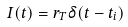Convert formula to latex. <formula><loc_0><loc_0><loc_500><loc_500>I ( t ) = r _ { T } \delta ( t - t _ { i } )</formula> 